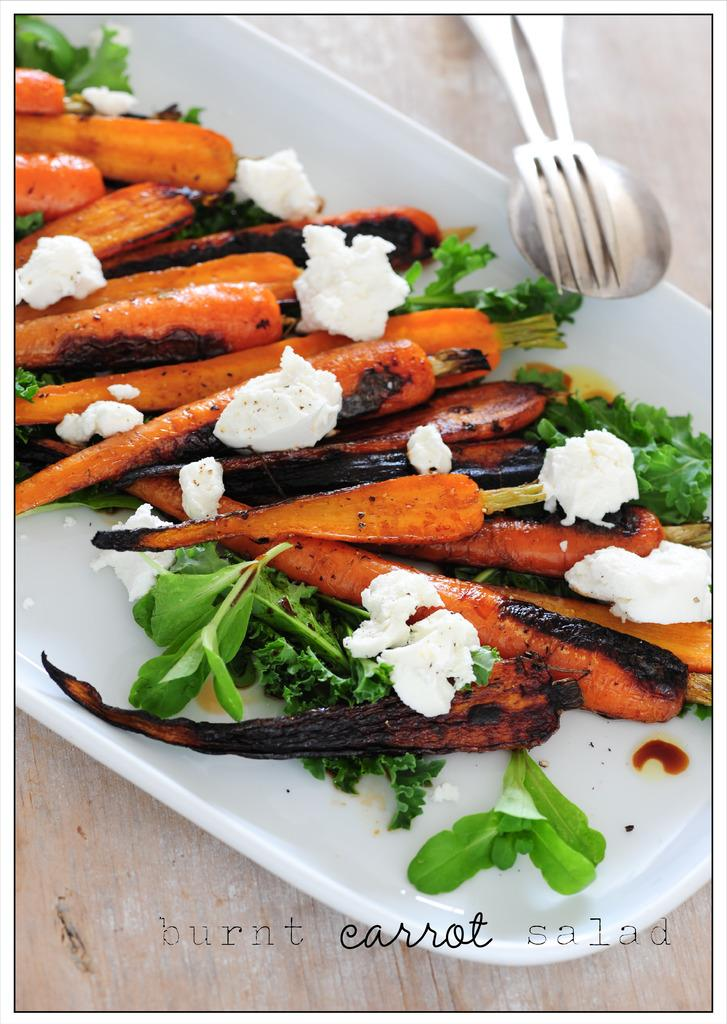What is on the tray that is visible in the image? There is a tray with carrots and food items in the image. What utensils are present in the image? There is a spoon and a fork in the image. What type of surface is the tray placed on? The wooden platform is present in the image. Is there any text in the image? Yes, there is text at the bottom of the image. Can you tell me how many bottles of oil are present in the image? There is no oil present in the image; it features a tray with carrots and food items, utensils, a wooden platform, and text. Is there a boy visible in the image? No, there is no boy present in the image. 